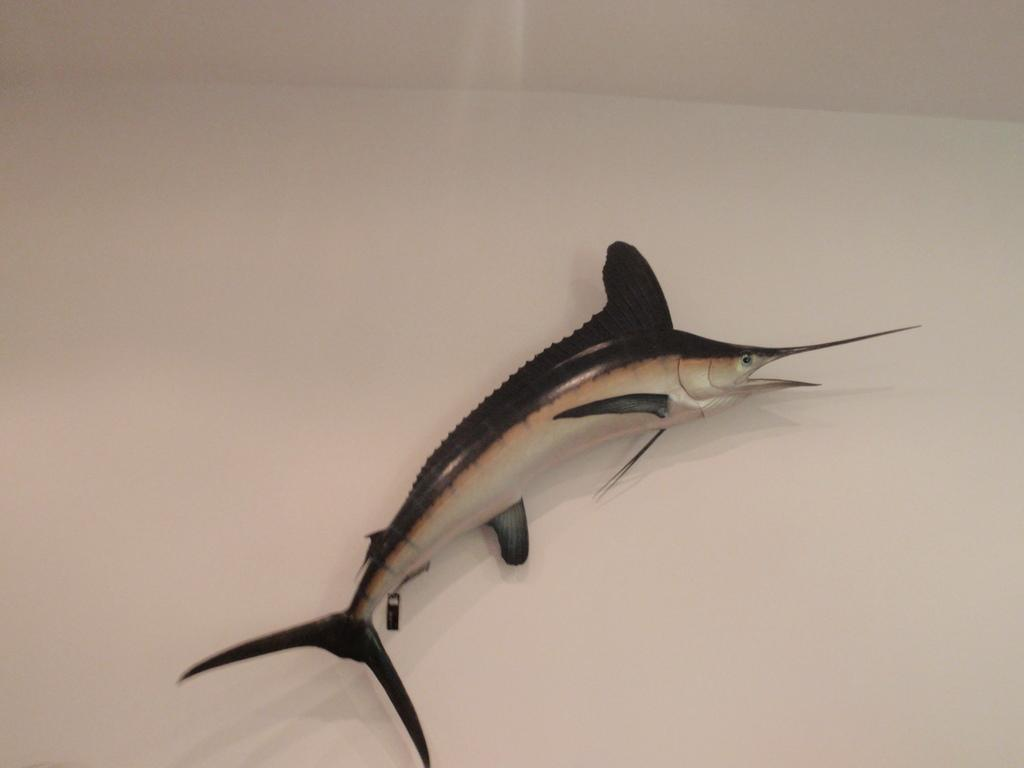What type of animal is in the image? There is a fish in the image. What color is the fish? The fish is black in color. What are two features that can be observed on the fish? The fish has an eye and a mouth. How many cakes are on the fish's head in the image? There are no cakes present in the image, and the fish does not have a head. Is there a squirrel visible in the image? No, there is no squirrel present in the image. 